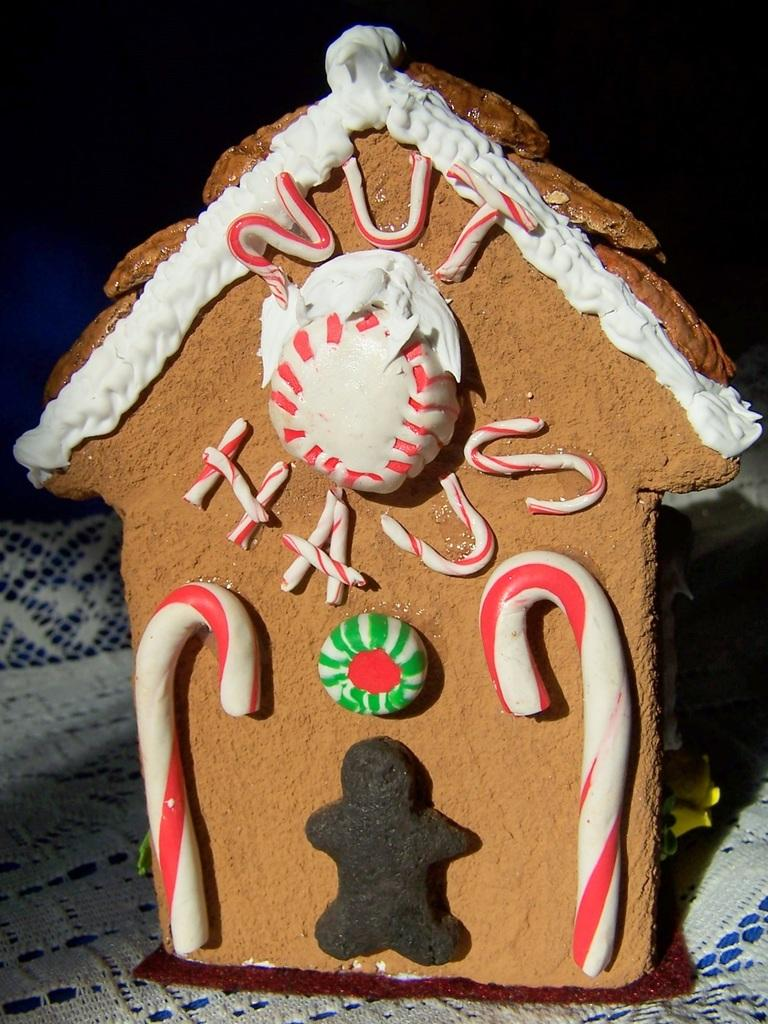What is the shape of the cookie in the image? The cookie in the image is in the shape of a house. What decorations are on the cookie? There are candies on the cookie. What can be observed about the overall lighting or color of the image? The background of the image is dark. What time does the clock on the cookie indicate? There is no clock present on the cookie, so it is not possible to determine the time. 